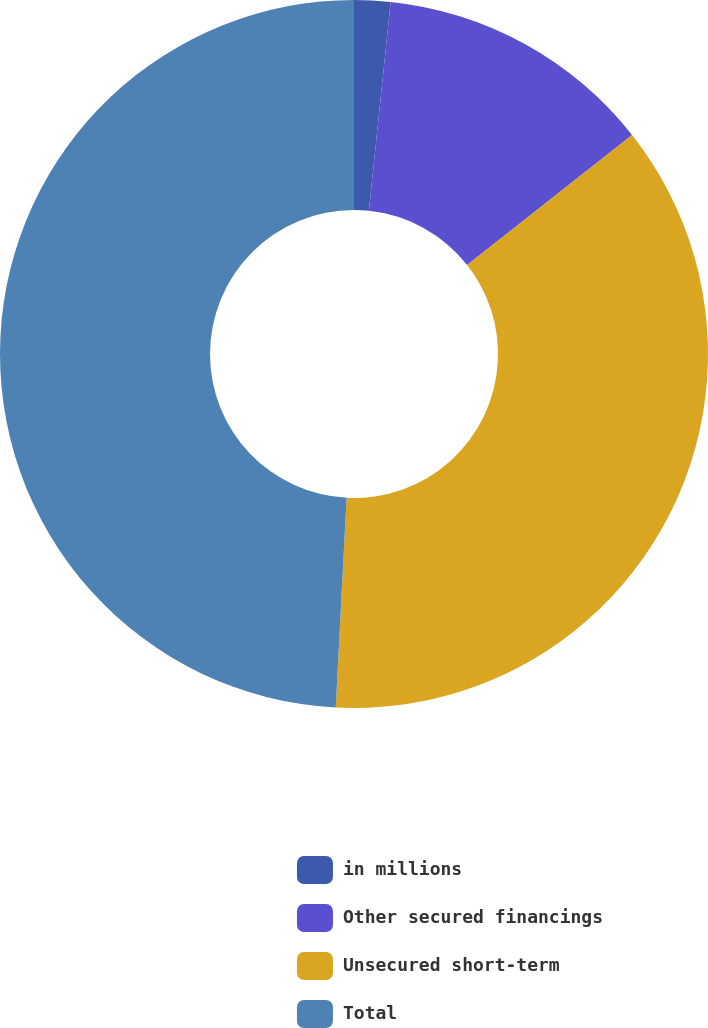Convert chart. <chart><loc_0><loc_0><loc_500><loc_500><pie_chart><fcel>in millions<fcel>Other secured financings<fcel>Unsecured short-term<fcel>Total<nl><fcel>1.65%<fcel>12.73%<fcel>36.44%<fcel>49.18%<nl></chart> 